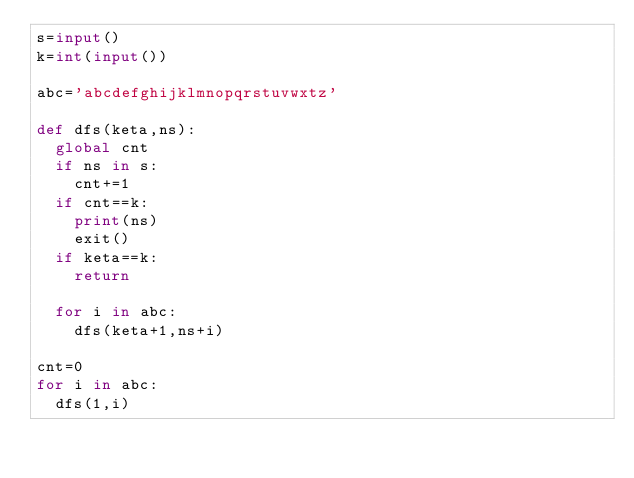<code> <loc_0><loc_0><loc_500><loc_500><_Python_>s=input()
k=int(input())

abc='abcdefghijklmnopqrstuvwxtz'

def dfs(keta,ns):
  global cnt
  if ns in s:
    cnt+=1
  if cnt==k:
    print(ns)
    exit()
  if keta==k:
    return

  for i in abc:
    dfs(keta+1,ns+i)

cnt=0
for i in abc:
  dfs(1,i)</code> 